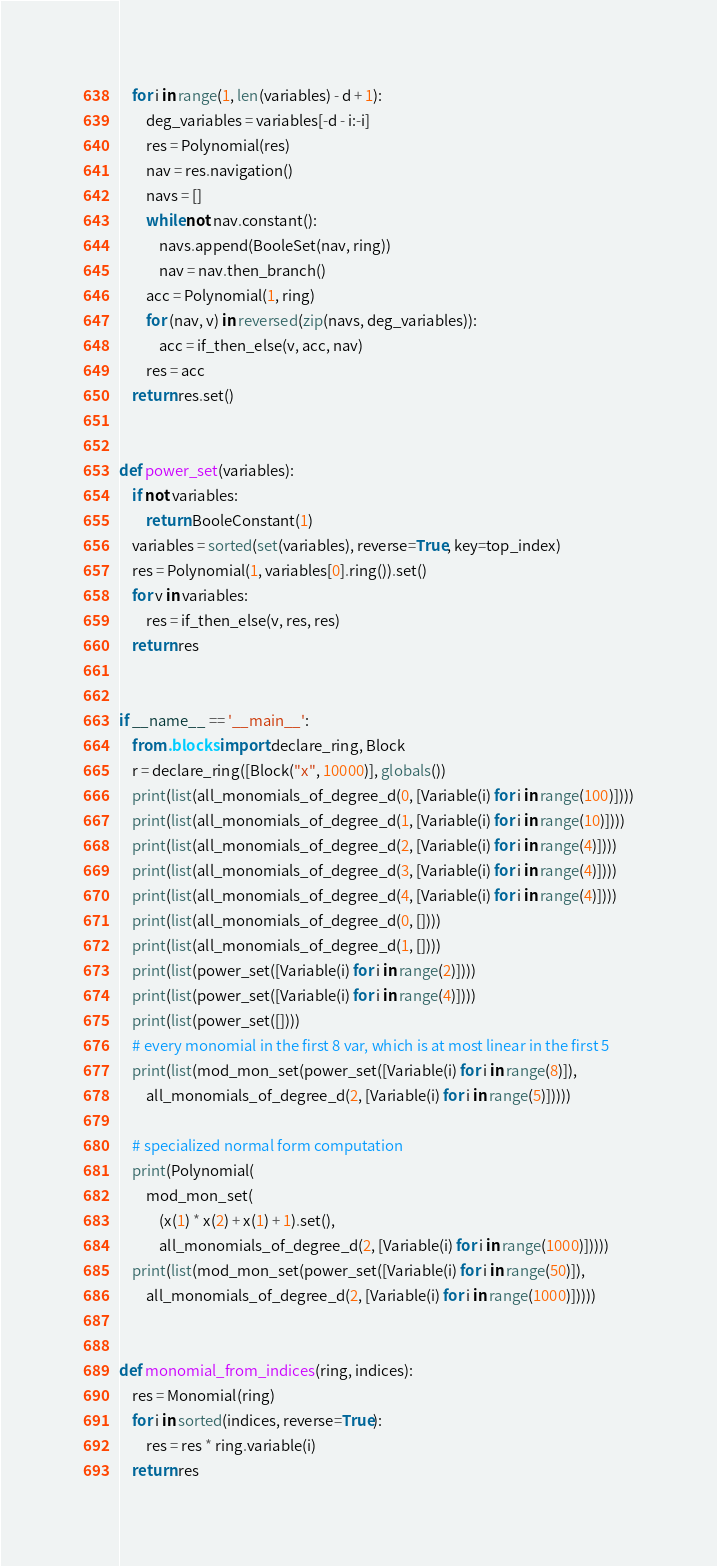Convert code to text. <code><loc_0><loc_0><loc_500><loc_500><_Python_>    for i in range(1, len(variables) - d + 1):
        deg_variables = variables[-d - i:-i]
        res = Polynomial(res)
        nav = res.navigation()
        navs = []
        while not nav.constant():
            navs.append(BooleSet(nav, ring))
            nav = nav.then_branch()
        acc = Polynomial(1, ring)
        for (nav, v) in reversed(zip(navs, deg_variables)):
            acc = if_then_else(v, acc, nav)
        res = acc
    return res.set()


def power_set(variables):
    if not variables:
        return BooleConstant(1)
    variables = sorted(set(variables), reverse=True, key=top_index)
    res = Polynomial(1, variables[0].ring()).set()
    for v in variables:
        res = if_then_else(v, res, res)
    return res


if __name__ == '__main__':
    from .blocks import declare_ring, Block
    r = declare_ring([Block("x", 10000)], globals())
    print(list(all_monomials_of_degree_d(0, [Variable(i) for i in range(100)])))
    print(list(all_monomials_of_degree_d(1, [Variable(i) for i in range(10)])))
    print(list(all_monomials_of_degree_d(2, [Variable(i) for i in range(4)])))
    print(list(all_monomials_of_degree_d(3, [Variable(i) for i in range(4)])))
    print(list(all_monomials_of_degree_d(4, [Variable(i) for i in range(4)])))
    print(list(all_monomials_of_degree_d(0, [])))
    print(list(all_monomials_of_degree_d(1, [])))
    print(list(power_set([Variable(i) for i in range(2)])))
    print(list(power_set([Variable(i) for i in range(4)])))
    print(list(power_set([])))
    # every monomial in the first 8 var, which is at most linear in the first 5
    print(list(mod_mon_set(power_set([Variable(i) for i in range(8)]),
        all_monomials_of_degree_d(2, [Variable(i) for i in range(5)]))))

    # specialized normal form computation
    print(Polynomial(
        mod_mon_set(
            (x(1) * x(2) + x(1) + 1).set(),
            all_monomials_of_degree_d(2, [Variable(i) for i in range(1000)]))))
    print(list(mod_mon_set(power_set([Variable(i) for i in range(50)]),
        all_monomials_of_degree_d(2, [Variable(i) for i in range(1000)]))))


def monomial_from_indices(ring, indices):
    res = Monomial(ring)
    for i in sorted(indices, reverse=True):
        res = res * ring.variable(i)
    return res
</code> 